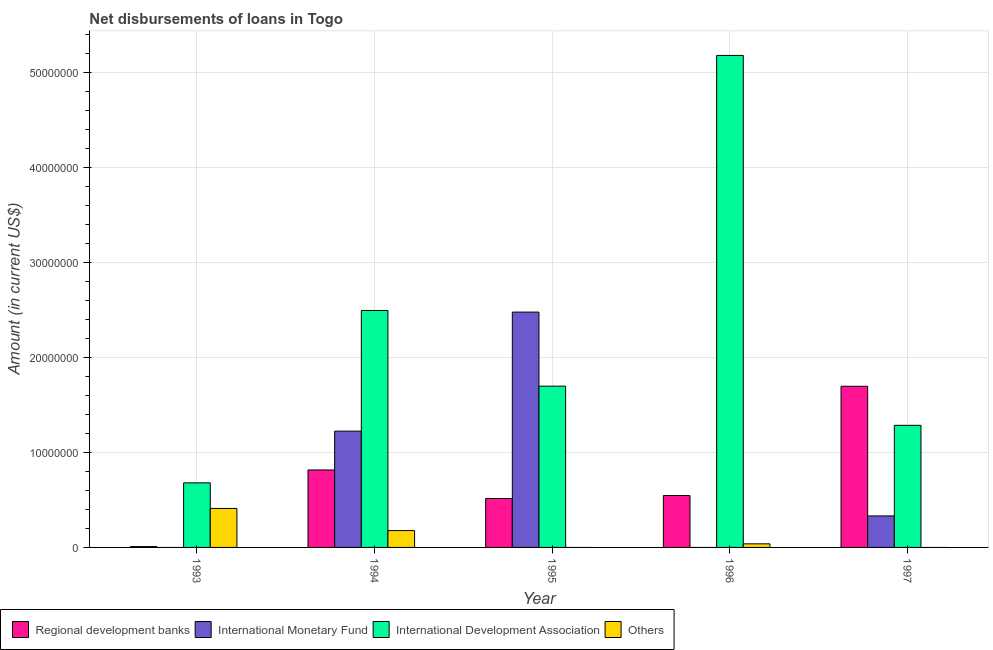How many different coloured bars are there?
Offer a very short reply. 4. Are the number of bars per tick equal to the number of legend labels?
Your response must be concise. No. In how many cases, is the number of bars for a given year not equal to the number of legend labels?
Your answer should be compact. 4. What is the amount of loan disimbursed by international development association in 1994?
Your answer should be very brief. 2.50e+07. Across all years, what is the maximum amount of loan disimbursed by regional development banks?
Offer a terse response. 1.70e+07. Across all years, what is the minimum amount of loan disimbursed by other organisations?
Ensure brevity in your answer.  0. In which year was the amount of loan disimbursed by other organisations maximum?
Ensure brevity in your answer.  1993. What is the total amount of loan disimbursed by international development association in the graph?
Ensure brevity in your answer.  1.13e+08. What is the difference between the amount of loan disimbursed by international development association in 1993 and that in 1994?
Offer a terse response. -1.82e+07. What is the difference between the amount of loan disimbursed by international development association in 1993 and the amount of loan disimbursed by other organisations in 1996?
Provide a short and direct response. -4.50e+07. What is the average amount of loan disimbursed by international monetary fund per year?
Offer a very short reply. 8.07e+06. In how many years, is the amount of loan disimbursed by other organisations greater than 4000000 US$?
Your answer should be very brief. 1. What is the ratio of the amount of loan disimbursed by international development association in 1995 to that in 1997?
Your answer should be very brief. 1.32. Is the amount of loan disimbursed by international development association in 1994 less than that in 1996?
Provide a succinct answer. Yes. What is the difference between the highest and the second highest amount of loan disimbursed by regional development banks?
Keep it short and to the point. 8.82e+06. What is the difference between the highest and the lowest amount of loan disimbursed by international development association?
Ensure brevity in your answer.  4.50e+07. In how many years, is the amount of loan disimbursed by international monetary fund greater than the average amount of loan disimbursed by international monetary fund taken over all years?
Provide a succinct answer. 2. Is the sum of the amount of loan disimbursed by regional development banks in 1995 and 1996 greater than the maximum amount of loan disimbursed by other organisations across all years?
Make the answer very short. No. Is it the case that in every year, the sum of the amount of loan disimbursed by regional development banks and amount of loan disimbursed by international monetary fund is greater than the amount of loan disimbursed by international development association?
Provide a short and direct response. No. How many bars are there?
Provide a short and direct response. 16. How many years are there in the graph?
Provide a succinct answer. 5. Are the values on the major ticks of Y-axis written in scientific E-notation?
Make the answer very short. No. Does the graph contain any zero values?
Your answer should be very brief. Yes. Does the graph contain grids?
Offer a very short reply. Yes. How many legend labels are there?
Keep it short and to the point. 4. How are the legend labels stacked?
Offer a very short reply. Horizontal. What is the title of the graph?
Make the answer very short. Net disbursements of loans in Togo. Does "UNTA" appear as one of the legend labels in the graph?
Provide a short and direct response. No. What is the label or title of the Y-axis?
Your response must be concise. Amount (in current US$). What is the Amount (in current US$) of Regional development banks in 1993?
Keep it short and to the point. 8.80e+04. What is the Amount (in current US$) of International Development Association in 1993?
Provide a succinct answer. 6.80e+06. What is the Amount (in current US$) of Others in 1993?
Keep it short and to the point. 4.11e+06. What is the Amount (in current US$) of Regional development banks in 1994?
Provide a short and direct response. 8.16e+06. What is the Amount (in current US$) of International Monetary Fund in 1994?
Your answer should be compact. 1.23e+07. What is the Amount (in current US$) of International Development Association in 1994?
Ensure brevity in your answer.  2.50e+07. What is the Amount (in current US$) of Others in 1994?
Make the answer very short. 1.78e+06. What is the Amount (in current US$) in Regional development banks in 1995?
Your answer should be compact. 5.15e+06. What is the Amount (in current US$) in International Monetary Fund in 1995?
Offer a terse response. 2.48e+07. What is the Amount (in current US$) of International Development Association in 1995?
Make the answer very short. 1.70e+07. What is the Amount (in current US$) of Others in 1995?
Offer a very short reply. 0. What is the Amount (in current US$) of Regional development banks in 1996?
Offer a terse response. 5.47e+06. What is the Amount (in current US$) in International Development Association in 1996?
Offer a very short reply. 5.18e+07. What is the Amount (in current US$) of Others in 1996?
Your response must be concise. 3.79e+05. What is the Amount (in current US$) of Regional development banks in 1997?
Make the answer very short. 1.70e+07. What is the Amount (in current US$) in International Monetary Fund in 1997?
Ensure brevity in your answer.  3.32e+06. What is the Amount (in current US$) of International Development Association in 1997?
Provide a succinct answer. 1.29e+07. What is the Amount (in current US$) in Others in 1997?
Your response must be concise. 0. Across all years, what is the maximum Amount (in current US$) of Regional development banks?
Your response must be concise. 1.70e+07. Across all years, what is the maximum Amount (in current US$) in International Monetary Fund?
Your answer should be compact. 2.48e+07. Across all years, what is the maximum Amount (in current US$) of International Development Association?
Make the answer very short. 5.18e+07. Across all years, what is the maximum Amount (in current US$) in Others?
Offer a very short reply. 4.11e+06. Across all years, what is the minimum Amount (in current US$) in Regional development banks?
Provide a succinct answer. 8.80e+04. Across all years, what is the minimum Amount (in current US$) in International Development Association?
Your answer should be very brief. 6.80e+06. Across all years, what is the minimum Amount (in current US$) of Others?
Keep it short and to the point. 0. What is the total Amount (in current US$) of Regional development banks in the graph?
Provide a short and direct response. 3.59e+07. What is the total Amount (in current US$) in International Monetary Fund in the graph?
Provide a succinct answer. 4.04e+07. What is the total Amount (in current US$) of International Development Association in the graph?
Provide a succinct answer. 1.13e+08. What is the total Amount (in current US$) of Others in the graph?
Keep it short and to the point. 6.26e+06. What is the difference between the Amount (in current US$) in Regional development banks in 1993 and that in 1994?
Provide a succinct answer. -8.07e+06. What is the difference between the Amount (in current US$) in International Development Association in 1993 and that in 1994?
Offer a very short reply. -1.82e+07. What is the difference between the Amount (in current US$) in Others in 1993 and that in 1994?
Your answer should be compact. 2.33e+06. What is the difference between the Amount (in current US$) of Regional development banks in 1993 and that in 1995?
Your answer should be compact. -5.07e+06. What is the difference between the Amount (in current US$) in International Development Association in 1993 and that in 1995?
Give a very brief answer. -1.02e+07. What is the difference between the Amount (in current US$) of Regional development banks in 1993 and that in 1996?
Offer a very short reply. -5.38e+06. What is the difference between the Amount (in current US$) of International Development Association in 1993 and that in 1996?
Provide a succinct answer. -4.50e+07. What is the difference between the Amount (in current US$) of Others in 1993 and that in 1996?
Provide a short and direct response. 3.73e+06. What is the difference between the Amount (in current US$) in Regional development banks in 1993 and that in 1997?
Offer a terse response. -1.69e+07. What is the difference between the Amount (in current US$) of International Development Association in 1993 and that in 1997?
Ensure brevity in your answer.  -6.06e+06. What is the difference between the Amount (in current US$) in Regional development banks in 1994 and that in 1995?
Your response must be concise. 3.01e+06. What is the difference between the Amount (in current US$) of International Monetary Fund in 1994 and that in 1995?
Keep it short and to the point. -1.25e+07. What is the difference between the Amount (in current US$) of International Development Association in 1994 and that in 1995?
Make the answer very short. 7.98e+06. What is the difference between the Amount (in current US$) of Regional development banks in 1994 and that in 1996?
Provide a succinct answer. 2.69e+06. What is the difference between the Amount (in current US$) in International Development Association in 1994 and that in 1996?
Provide a succinct answer. -2.69e+07. What is the difference between the Amount (in current US$) in Others in 1994 and that in 1996?
Provide a short and direct response. 1.40e+06. What is the difference between the Amount (in current US$) in Regional development banks in 1994 and that in 1997?
Offer a very short reply. -8.82e+06. What is the difference between the Amount (in current US$) of International Monetary Fund in 1994 and that in 1997?
Ensure brevity in your answer.  8.93e+06. What is the difference between the Amount (in current US$) in International Development Association in 1994 and that in 1997?
Offer a terse response. 1.21e+07. What is the difference between the Amount (in current US$) in Regional development banks in 1995 and that in 1996?
Your answer should be very brief. -3.13e+05. What is the difference between the Amount (in current US$) in International Development Association in 1995 and that in 1996?
Offer a terse response. -3.48e+07. What is the difference between the Amount (in current US$) in Regional development banks in 1995 and that in 1997?
Keep it short and to the point. -1.18e+07. What is the difference between the Amount (in current US$) of International Monetary Fund in 1995 and that in 1997?
Offer a very short reply. 2.15e+07. What is the difference between the Amount (in current US$) of International Development Association in 1995 and that in 1997?
Your response must be concise. 4.12e+06. What is the difference between the Amount (in current US$) in Regional development banks in 1996 and that in 1997?
Give a very brief answer. -1.15e+07. What is the difference between the Amount (in current US$) of International Development Association in 1996 and that in 1997?
Offer a terse response. 3.90e+07. What is the difference between the Amount (in current US$) in Regional development banks in 1993 and the Amount (in current US$) in International Monetary Fund in 1994?
Offer a very short reply. -1.22e+07. What is the difference between the Amount (in current US$) in Regional development banks in 1993 and the Amount (in current US$) in International Development Association in 1994?
Offer a very short reply. -2.49e+07. What is the difference between the Amount (in current US$) in Regional development banks in 1993 and the Amount (in current US$) in Others in 1994?
Ensure brevity in your answer.  -1.69e+06. What is the difference between the Amount (in current US$) of International Development Association in 1993 and the Amount (in current US$) of Others in 1994?
Make the answer very short. 5.03e+06. What is the difference between the Amount (in current US$) in Regional development banks in 1993 and the Amount (in current US$) in International Monetary Fund in 1995?
Keep it short and to the point. -2.47e+07. What is the difference between the Amount (in current US$) of Regional development banks in 1993 and the Amount (in current US$) of International Development Association in 1995?
Ensure brevity in your answer.  -1.69e+07. What is the difference between the Amount (in current US$) of Regional development banks in 1993 and the Amount (in current US$) of International Development Association in 1996?
Your response must be concise. -5.18e+07. What is the difference between the Amount (in current US$) of Regional development banks in 1993 and the Amount (in current US$) of Others in 1996?
Offer a terse response. -2.91e+05. What is the difference between the Amount (in current US$) in International Development Association in 1993 and the Amount (in current US$) in Others in 1996?
Keep it short and to the point. 6.42e+06. What is the difference between the Amount (in current US$) of Regional development banks in 1993 and the Amount (in current US$) of International Monetary Fund in 1997?
Make the answer very short. -3.23e+06. What is the difference between the Amount (in current US$) in Regional development banks in 1993 and the Amount (in current US$) in International Development Association in 1997?
Offer a terse response. -1.28e+07. What is the difference between the Amount (in current US$) in Regional development banks in 1994 and the Amount (in current US$) in International Monetary Fund in 1995?
Provide a short and direct response. -1.66e+07. What is the difference between the Amount (in current US$) in Regional development banks in 1994 and the Amount (in current US$) in International Development Association in 1995?
Your answer should be compact. -8.83e+06. What is the difference between the Amount (in current US$) of International Monetary Fund in 1994 and the Amount (in current US$) of International Development Association in 1995?
Provide a succinct answer. -4.74e+06. What is the difference between the Amount (in current US$) of Regional development banks in 1994 and the Amount (in current US$) of International Development Association in 1996?
Offer a terse response. -4.37e+07. What is the difference between the Amount (in current US$) in Regional development banks in 1994 and the Amount (in current US$) in Others in 1996?
Ensure brevity in your answer.  7.78e+06. What is the difference between the Amount (in current US$) of International Monetary Fund in 1994 and the Amount (in current US$) of International Development Association in 1996?
Provide a short and direct response. -3.96e+07. What is the difference between the Amount (in current US$) in International Monetary Fund in 1994 and the Amount (in current US$) in Others in 1996?
Offer a very short reply. 1.19e+07. What is the difference between the Amount (in current US$) of International Development Association in 1994 and the Amount (in current US$) of Others in 1996?
Offer a terse response. 2.46e+07. What is the difference between the Amount (in current US$) of Regional development banks in 1994 and the Amount (in current US$) of International Monetary Fund in 1997?
Provide a short and direct response. 4.84e+06. What is the difference between the Amount (in current US$) in Regional development banks in 1994 and the Amount (in current US$) in International Development Association in 1997?
Make the answer very short. -4.70e+06. What is the difference between the Amount (in current US$) in International Monetary Fund in 1994 and the Amount (in current US$) in International Development Association in 1997?
Provide a short and direct response. -6.13e+05. What is the difference between the Amount (in current US$) in Regional development banks in 1995 and the Amount (in current US$) in International Development Association in 1996?
Ensure brevity in your answer.  -4.67e+07. What is the difference between the Amount (in current US$) of Regional development banks in 1995 and the Amount (in current US$) of Others in 1996?
Your response must be concise. 4.78e+06. What is the difference between the Amount (in current US$) in International Monetary Fund in 1995 and the Amount (in current US$) in International Development Association in 1996?
Your answer should be very brief. -2.70e+07. What is the difference between the Amount (in current US$) of International Monetary Fund in 1995 and the Amount (in current US$) of Others in 1996?
Make the answer very short. 2.44e+07. What is the difference between the Amount (in current US$) of International Development Association in 1995 and the Amount (in current US$) of Others in 1996?
Provide a short and direct response. 1.66e+07. What is the difference between the Amount (in current US$) of Regional development banks in 1995 and the Amount (in current US$) of International Monetary Fund in 1997?
Make the answer very short. 1.84e+06. What is the difference between the Amount (in current US$) of Regional development banks in 1995 and the Amount (in current US$) of International Development Association in 1997?
Your answer should be compact. -7.71e+06. What is the difference between the Amount (in current US$) of International Monetary Fund in 1995 and the Amount (in current US$) of International Development Association in 1997?
Provide a short and direct response. 1.19e+07. What is the difference between the Amount (in current US$) in Regional development banks in 1996 and the Amount (in current US$) in International Monetary Fund in 1997?
Your response must be concise. 2.15e+06. What is the difference between the Amount (in current US$) of Regional development banks in 1996 and the Amount (in current US$) of International Development Association in 1997?
Ensure brevity in your answer.  -7.40e+06. What is the average Amount (in current US$) of Regional development banks per year?
Your answer should be compact. 7.17e+06. What is the average Amount (in current US$) of International Monetary Fund per year?
Provide a short and direct response. 8.07e+06. What is the average Amount (in current US$) of International Development Association per year?
Your answer should be compact. 2.27e+07. What is the average Amount (in current US$) in Others per year?
Keep it short and to the point. 1.25e+06. In the year 1993, what is the difference between the Amount (in current US$) in Regional development banks and Amount (in current US$) in International Development Association?
Ensure brevity in your answer.  -6.72e+06. In the year 1993, what is the difference between the Amount (in current US$) of Regional development banks and Amount (in current US$) of Others?
Your response must be concise. -4.02e+06. In the year 1993, what is the difference between the Amount (in current US$) of International Development Association and Amount (in current US$) of Others?
Your answer should be very brief. 2.70e+06. In the year 1994, what is the difference between the Amount (in current US$) in Regional development banks and Amount (in current US$) in International Monetary Fund?
Offer a very short reply. -4.09e+06. In the year 1994, what is the difference between the Amount (in current US$) of Regional development banks and Amount (in current US$) of International Development Association?
Make the answer very short. -1.68e+07. In the year 1994, what is the difference between the Amount (in current US$) in Regional development banks and Amount (in current US$) in Others?
Ensure brevity in your answer.  6.38e+06. In the year 1994, what is the difference between the Amount (in current US$) of International Monetary Fund and Amount (in current US$) of International Development Association?
Provide a succinct answer. -1.27e+07. In the year 1994, what is the difference between the Amount (in current US$) of International Monetary Fund and Amount (in current US$) of Others?
Ensure brevity in your answer.  1.05e+07. In the year 1994, what is the difference between the Amount (in current US$) in International Development Association and Amount (in current US$) in Others?
Offer a very short reply. 2.32e+07. In the year 1995, what is the difference between the Amount (in current US$) of Regional development banks and Amount (in current US$) of International Monetary Fund?
Your answer should be compact. -1.96e+07. In the year 1995, what is the difference between the Amount (in current US$) of Regional development banks and Amount (in current US$) of International Development Association?
Keep it short and to the point. -1.18e+07. In the year 1995, what is the difference between the Amount (in current US$) of International Monetary Fund and Amount (in current US$) of International Development Association?
Provide a short and direct response. 7.81e+06. In the year 1996, what is the difference between the Amount (in current US$) of Regional development banks and Amount (in current US$) of International Development Association?
Keep it short and to the point. -4.64e+07. In the year 1996, what is the difference between the Amount (in current US$) of Regional development banks and Amount (in current US$) of Others?
Offer a very short reply. 5.09e+06. In the year 1996, what is the difference between the Amount (in current US$) of International Development Association and Amount (in current US$) of Others?
Keep it short and to the point. 5.15e+07. In the year 1997, what is the difference between the Amount (in current US$) in Regional development banks and Amount (in current US$) in International Monetary Fund?
Offer a terse response. 1.37e+07. In the year 1997, what is the difference between the Amount (in current US$) in Regional development banks and Amount (in current US$) in International Development Association?
Offer a very short reply. 4.12e+06. In the year 1997, what is the difference between the Amount (in current US$) of International Monetary Fund and Amount (in current US$) of International Development Association?
Your answer should be compact. -9.55e+06. What is the ratio of the Amount (in current US$) in Regional development banks in 1993 to that in 1994?
Provide a succinct answer. 0.01. What is the ratio of the Amount (in current US$) of International Development Association in 1993 to that in 1994?
Your answer should be compact. 0.27. What is the ratio of the Amount (in current US$) in Others in 1993 to that in 1994?
Keep it short and to the point. 2.31. What is the ratio of the Amount (in current US$) in Regional development banks in 1993 to that in 1995?
Give a very brief answer. 0.02. What is the ratio of the Amount (in current US$) in International Development Association in 1993 to that in 1995?
Offer a very short reply. 0.4. What is the ratio of the Amount (in current US$) in Regional development banks in 1993 to that in 1996?
Offer a very short reply. 0.02. What is the ratio of the Amount (in current US$) in International Development Association in 1993 to that in 1996?
Provide a short and direct response. 0.13. What is the ratio of the Amount (in current US$) of Others in 1993 to that in 1996?
Make the answer very short. 10.84. What is the ratio of the Amount (in current US$) in Regional development banks in 1993 to that in 1997?
Give a very brief answer. 0.01. What is the ratio of the Amount (in current US$) in International Development Association in 1993 to that in 1997?
Your answer should be very brief. 0.53. What is the ratio of the Amount (in current US$) of Regional development banks in 1994 to that in 1995?
Make the answer very short. 1.58. What is the ratio of the Amount (in current US$) of International Monetary Fund in 1994 to that in 1995?
Offer a very short reply. 0.49. What is the ratio of the Amount (in current US$) in International Development Association in 1994 to that in 1995?
Ensure brevity in your answer.  1.47. What is the ratio of the Amount (in current US$) of Regional development banks in 1994 to that in 1996?
Your answer should be compact. 1.49. What is the ratio of the Amount (in current US$) of International Development Association in 1994 to that in 1996?
Offer a terse response. 0.48. What is the ratio of the Amount (in current US$) in Others in 1994 to that in 1996?
Provide a short and direct response. 4.69. What is the ratio of the Amount (in current US$) of Regional development banks in 1994 to that in 1997?
Give a very brief answer. 0.48. What is the ratio of the Amount (in current US$) of International Monetary Fund in 1994 to that in 1997?
Give a very brief answer. 3.69. What is the ratio of the Amount (in current US$) in International Development Association in 1994 to that in 1997?
Make the answer very short. 1.94. What is the ratio of the Amount (in current US$) of Regional development banks in 1995 to that in 1996?
Keep it short and to the point. 0.94. What is the ratio of the Amount (in current US$) of International Development Association in 1995 to that in 1996?
Keep it short and to the point. 0.33. What is the ratio of the Amount (in current US$) of Regional development banks in 1995 to that in 1997?
Provide a succinct answer. 0.3. What is the ratio of the Amount (in current US$) of International Monetary Fund in 1995 to that in 1997?
Offer a terse response. 7.47. What is the ratio of the Amount (in current US$) of International Development Association in 1995 to that in 1997?
Your response must be concise. 1.32. What is the ratio of the Amount (in current US$) of Regional development banks in 1996 to that in 1997?
Give a very brief answer. 0.32. What is the ratio of the Amount (in current US$) in International Development Association in 1996 to that in 1997?
Keep it short and to the point. 4.03. What is the difference between the highest and the second highest Amount (in current US$) in Regional development banks?
Offer a very short reply. 8.82e+06. What is the difference between the highest and the second highest Amount (in current US$) of International Monetary Fund?
Give a very brief answer. 1.25e+07. What is the difference between the highest and the second highest Amount (in current US$) in International Development Association?
Provide a succinct answer. 2.69e+07. What is the difference between the highest and the second highest Amount (in current US$) of Others?
Offer a terse response. 2.33e+06. What is the difference between the highest and the lowest Amount (in current US$) in Regional development banks?
Offer a very short reply. 1.69e+07. What is the difference between the highest and the lowest Amount (in current US$) of International Monetary Fund?
Offer a terse response. 2.48e+07. What is the difference between the highest and the lowest Amount (in current US$) of International Development Association?
Offer a very short reply. 4.50e+07. What is the difference between the highest and the lowest Amount (in current US$) of Others?
Your answer should be compact. 4.11e+06. 